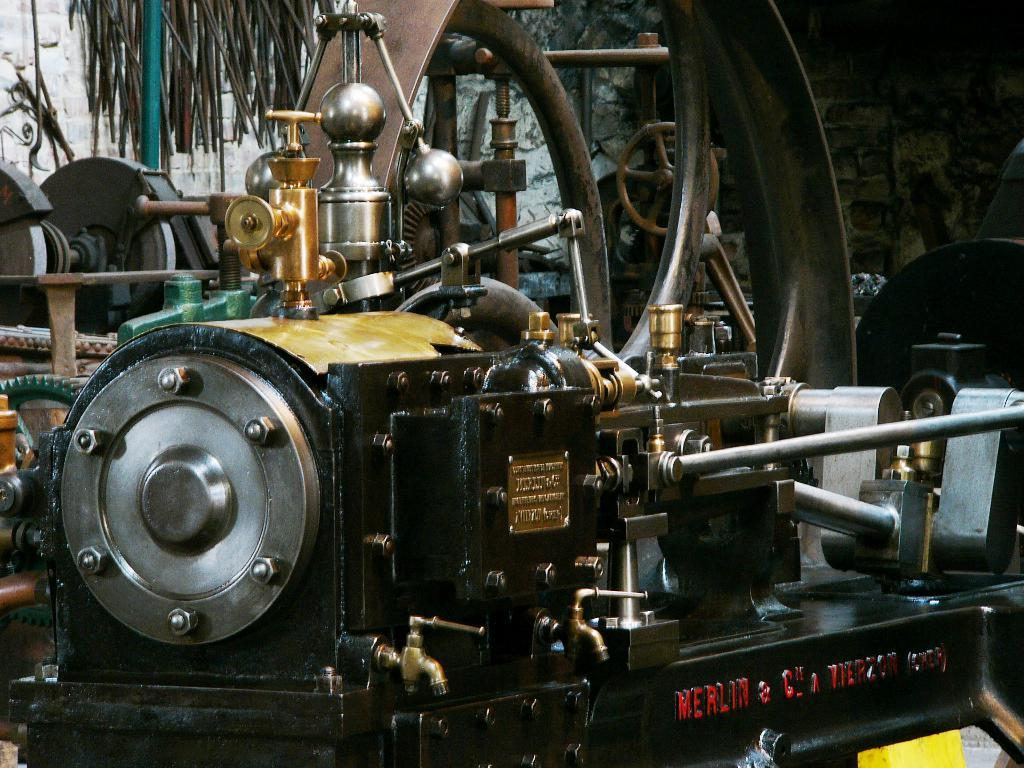What is the main subject of the image? The main subject of the image is an engine of a vehicle. Can you describe any other elements in the image? Yes, there is a wall visible in the image. What type of cemetery can be seen in the image? There is no cemetery present in the image; it features an engine of a vehicle and a wall. What kind of arch is visible in the image? There is no arch present in the image. 